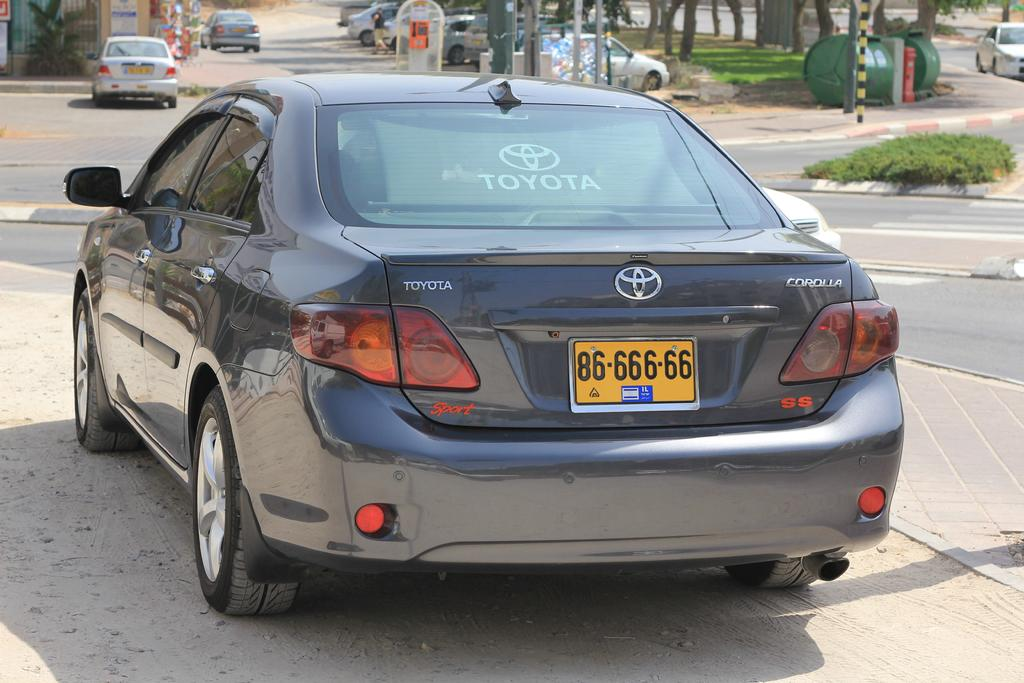<image>
Render a clear and concise summary of the photo. Black car with a yellow license plate that says 8666666. 